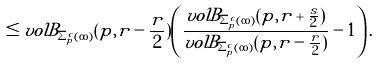<formula> <loc_0><loc_0><loc_500><loc_500>\leq v o l B _ { \Sigma _ { p } ^ { c } ( \infty ) } ( p , r - \frac { r } { 2 } ) \left ( \frac { v o l B _ { \Sigma _ { p } ^ { c } ( \infty ) } ( p , r + \frac { s } { 2 } ) } { v o l B _ { \Sigma _ { p } ^ { c } ( \infty ) } ( p , r - \frac { r } { 2 } ) } - 1 \right ) .</formula> 